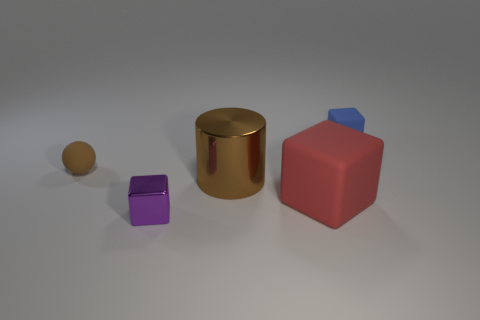Subtract all small cubes. How many cubes are left? 1 Subtract 2 cubes. How many cubes are left? 1 Subtract all red cubes. How many cubes are left? 2 Add 2 red blocks. How many objects exist? 7 Subtract all cylinders. How many objects are left? 4 Subtract all small matte objects. Subtract all brown cylinders. How many objects are left? 2 Add 4 large brown shiny cylinders. How many large brown shiny cylinders are left? 5 Add 5 large purple matte cylinders. How many large purple matte cylinders exist? 5 Subtract 0 purple cylinders. How many objects are left? 5 Subtract all blue cubes. Subtract all green balls. How many cubes are left? 2 